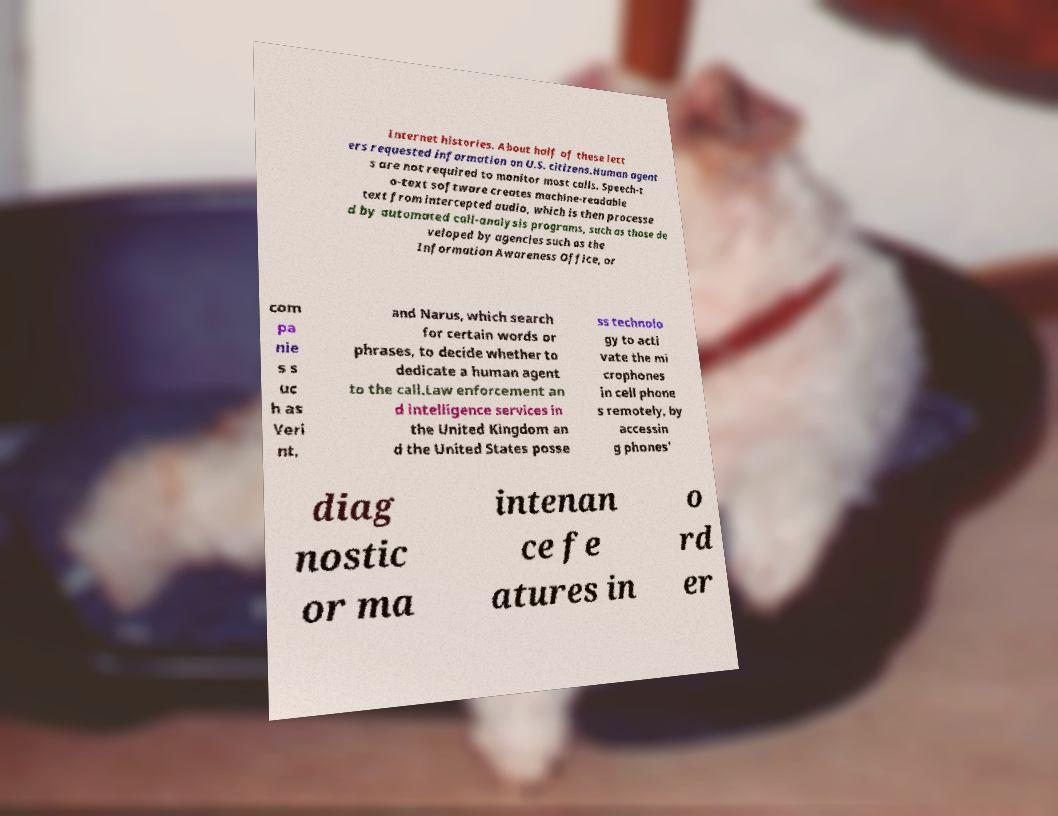There's text embedded in this image that I need extracted. Can you transcribe it verbatim? Internet histories. About half of these lett ers requested information on U.S. citizens.Human agent s are not required to monitor most calls. Speech-t o-text software creates machine-readable text from intercepted audio, which is then processe d by automated call-analysis programs, such as those de veloped by agencies such as the Information Awareness Office, or com pa nie s s uc h as Veri nt, and Narus, which search for certain words or phrases, to decide whether to dedicate a human agent to the call.Law enforcement an d intelligence services in the United Kingdom an d the United States posse ss technolo gy to acti vate the mi crophones in cell phone s remotely, by accessin g phones' diag nostic or ma intenan ce fe atures in o rd er 